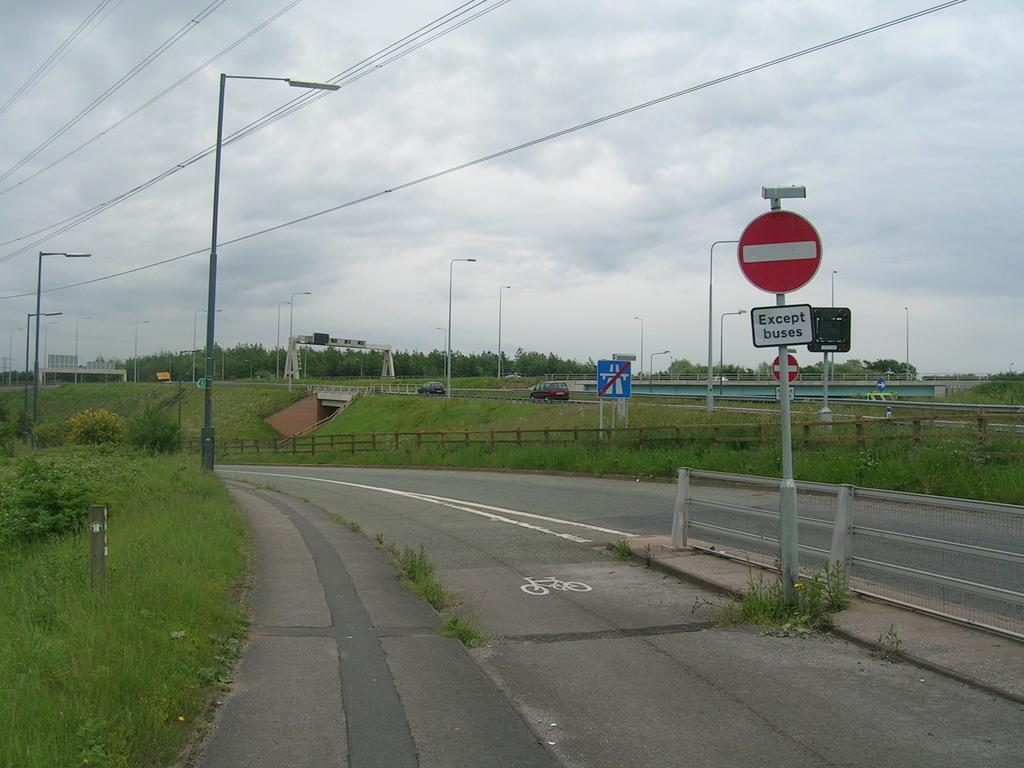<image>
Render a clear and concise summary of the photo. A roadway designed only for buses to enter. 